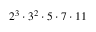Convert formula to latex. <formula><loc_0><loc_0><loc_500><loc_500>2 ^ { 3 } \cdot 3 ^ { 2 } \cdot 5 \cdot 7 \cdot 1 1</formula> 